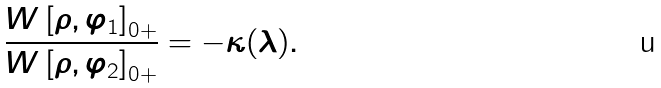<formula> <loc_0><loc_0><loc_500><loc_500>\frac { W \left [ \rho , \varphi _ { 1 } \right ] _ { 0 + } } { W \left [ \rho , \varphi _ { 2 } \right ] _ { 0 + } } = - \kappa ( \lambda ) .</formula> 